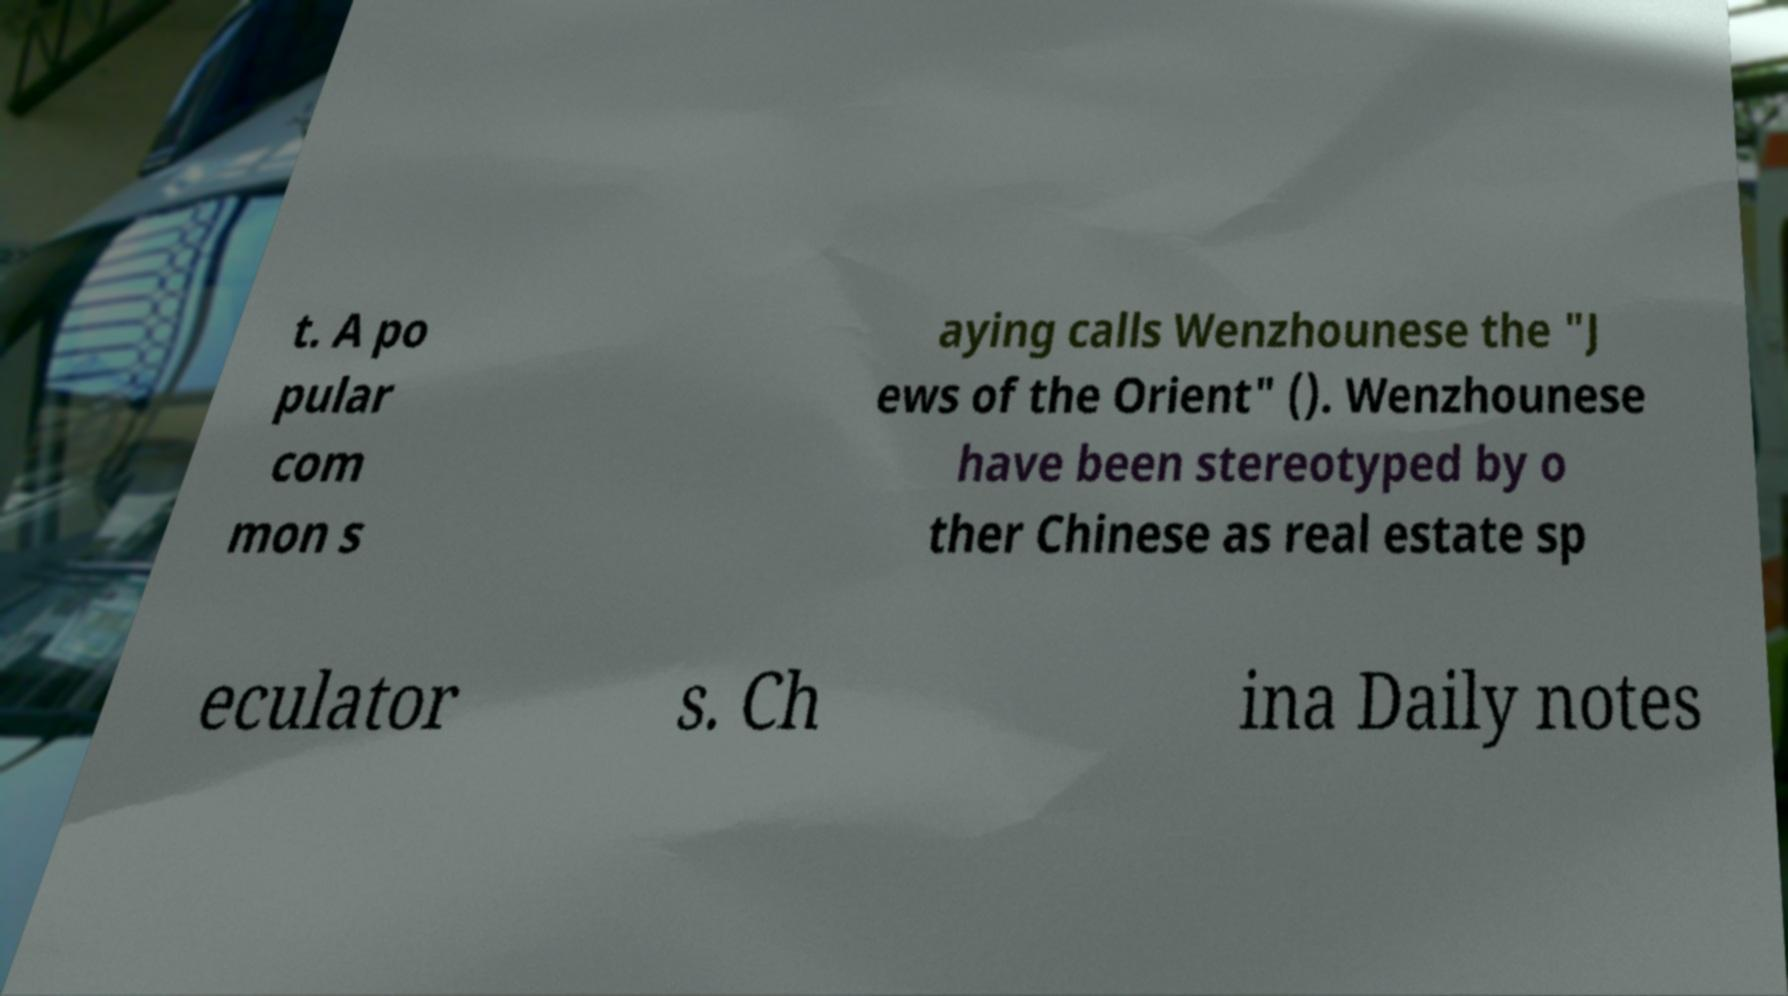I need the written content from this picture converted into text. Can you do that? t. A po pular com mon s aying calls Wenzhounese the "J ews of the Orient" (). Wenzhounese have been stereotyped by o ther Chinese as real estate sp eculator s. Ch ina Daily notes 